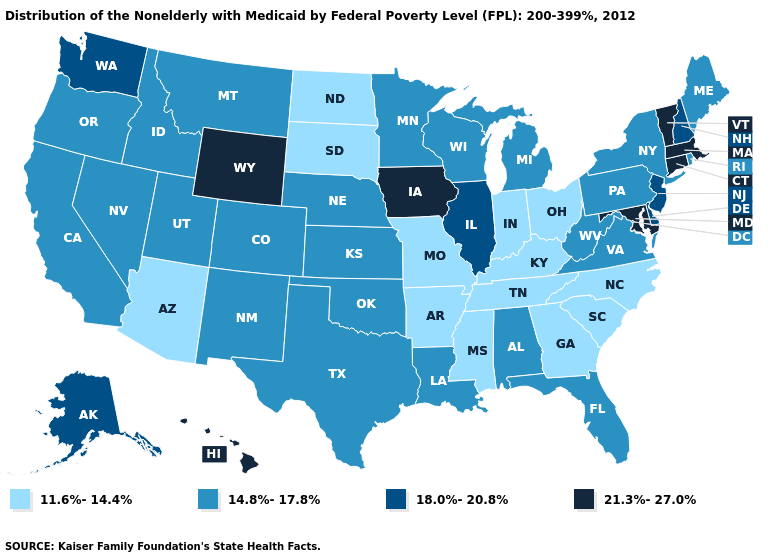What is the highest value in states that border Maryland?
Answer briefly. 18.0%-20.8%. What is the value of Pennsylvania?
Be succinct. 14.8%-17.8%. Among the states that border Connecticut , which have the lowest value?
Keep it brief. New York, Rhode Island. Name the states that have a value in the range 14.8%-17.8%?
Write a very short answer. Alabama, California, Colorado, Florida, Idaho, Kansas, Louisiana, Maine, Michigan, Minnesota, Montana, Nebraska, Nevada, New Mexico, New York, Oklahoma, Oregon, Pennsylvania, Rhode Island, Texas, Utah, Virginia, West Virginia, Wisconsin. Does the first symbol in the legend represent the smallest category?
Short answer required. Yes. What is the value of Connecticut?
Be succinct. 21.3%-27.0%. Does Illinois have the same value as Kentucky?
Short answer required. No. What is the value of South Carolina?
Be succinct. 11.6%-14.4%. What is the value of California?
Write a very short answer. 14.8%-17.8%. Name the states that have a value in the range 14.8%-17.8%?
Answer briefly. Alabama, California, Colorado, Florida, Idaho, Kansas, Louisiana, Maine, Michigan, Minnesota, Montana, Nebraska, Nevada, New Mexico, New York, Oklahoma, Oregon, Pennsylvania, Rhode Island, Texas, Utah, Virginia, West Virginia, Wisconsin. What is the value of Connecticut?
Write a very short answer. 21.3%-27.0%. Does Washington have a lower value than Kentucky?
Give a very brief answer. No. Does the first symbol in the legend represent the smallest category?
Concise answer only. Yes. What is the value of Hawaii?
Write a very short answer. 21.3%-27.0%. 